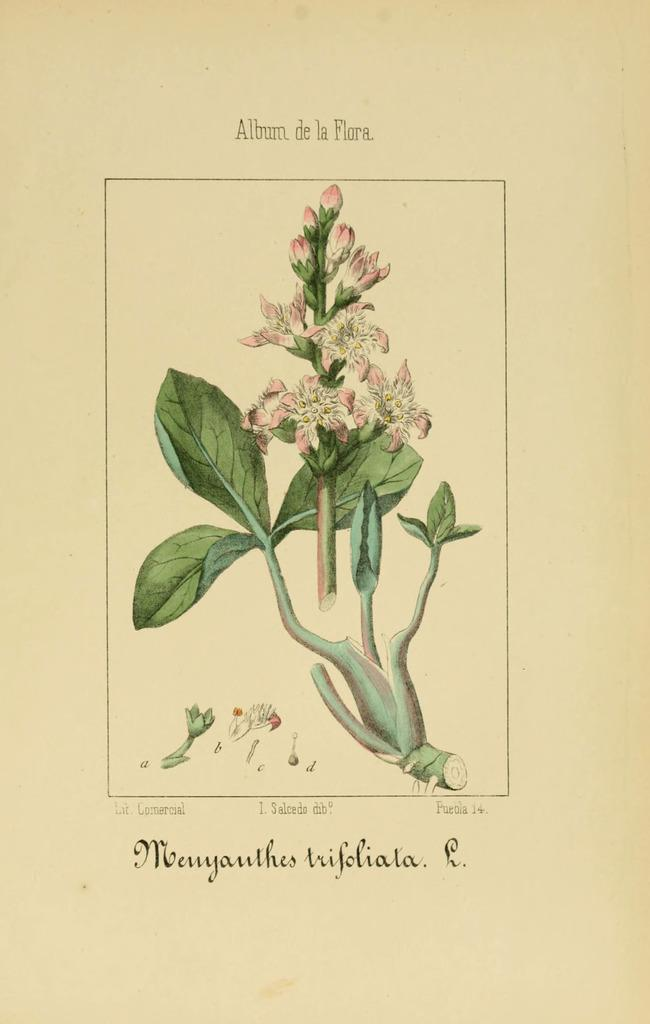What type of plant life can be seen in the image? There are flowers and leaves present in the image. Can you describe the text at the bottom of the image? Unfortunately, the provided facts do not give any information about the text at the bottom of the image. What is the primary focus of the image? Based on the facts provided, the primary focus of the image appears to be the flowers and leaves. Is there a beetle crawling on the flowers in the image? There is no mention of a beetle in the provided facts, so we cannot determine if one is present in the image. 